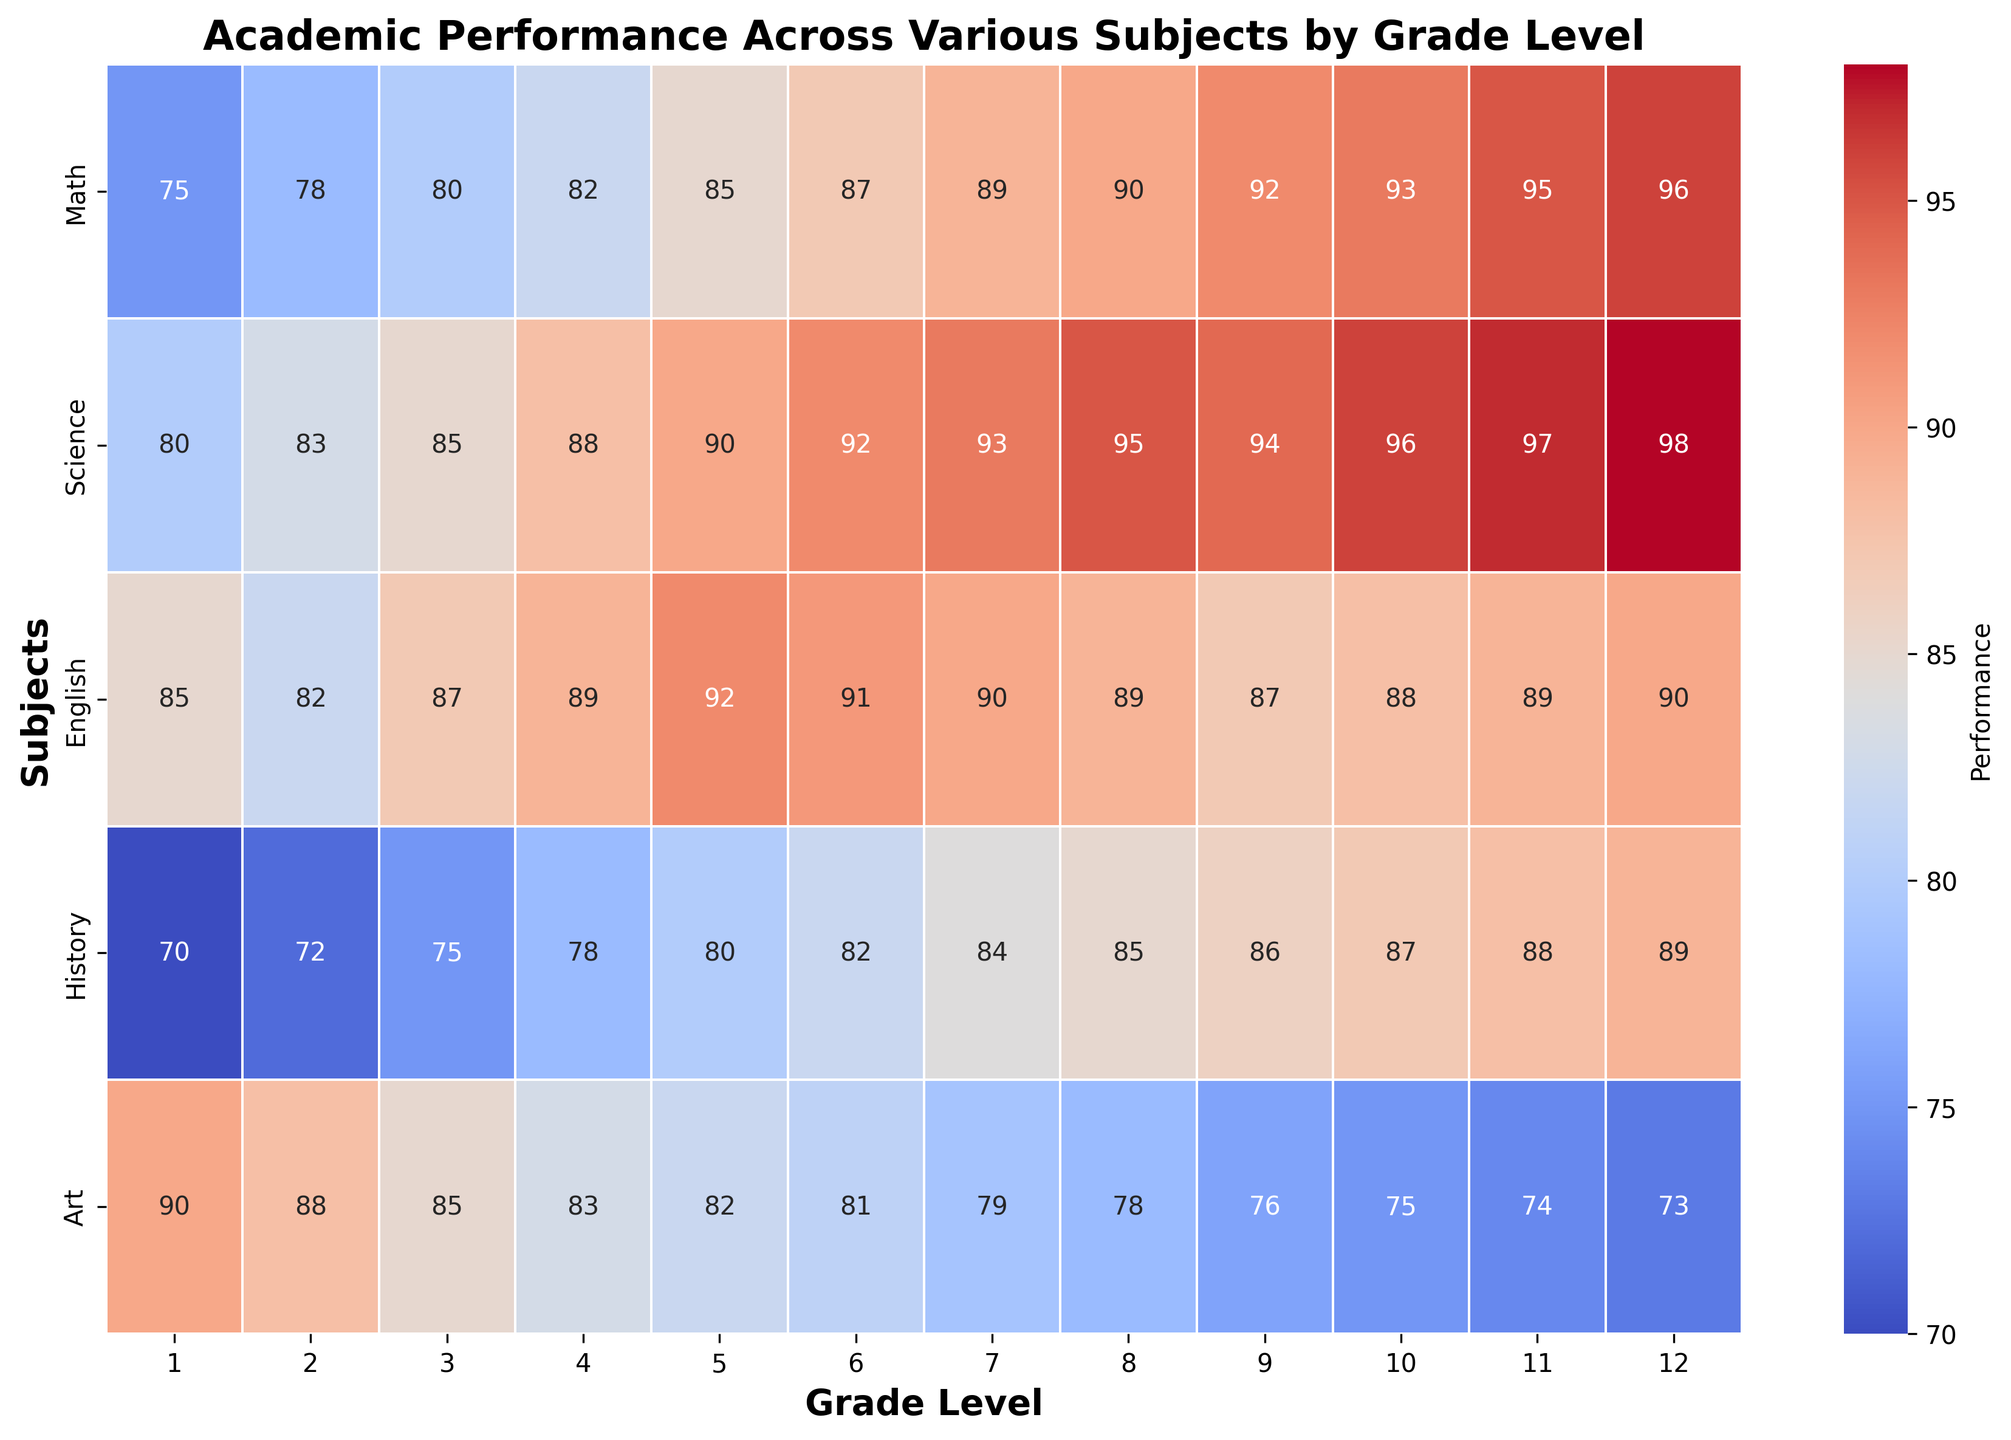What grade level has the highest average performance across all subjects? To find the grade level with the highest average performance, we need to calculate the average score for each grade level across all subjects. Grade 12 has the highest average of (96 + 98 + 90 + 89 + 73)/5 = 89.2.
Answer: Grade 12 Which subject shows the most significant improvement from Grade 1 to Grade 12? By comparing the scores from Grade 1 to Grade 12, Math goes from 75 to 96 (an increase of 21), Science goes from 80 to 98 (an increase of 18), English goes from 85 to 90 (an increase of 5), History goes from 70 to 89 (an increase of 19), and Art goes from 90 to 73 (a decrease). Math has the largest improvement with an increase of 21.
Answer: Math Are there any subjects where performance declines as grade level increases? Checking the scores from Grade 1 to Grade 12, we see that Art scores decline from 90 to 73 as the grade level increases.
Answer: Art What are the average scores for Science and History in Grade 8? The Science score for Grade 8 is 95 and the History score is 85. The average is (95 + 85) / 2 = 90.
Answer: 90 Is the performance in English higher in Grade 7 or Grade 11? In Grade 7, the English score is 90, while in Grade 11, it is 89. Therefore, the performance in English is higher in Grade 7.
Answer: Grade 7 Which grade level has the highest performance in Science and does it differ from the grade with the highest performance in English? The grade level with the highest performance in Science is Grade 12 with a score of 98. For English, the highest performance is also observed in Grade 5 with a score of 92.
Answer: No How does the Math score in Grade 6 compare to the History score in Grade 10? The Math score in Grade 6 is 87 and the History score in Grade 10 is 87. Therefore, both have the same score of 87.
Answer: Equal Between Grades 5 and 6, which grade shows better overall performance across all subjects? To determine this, find the average scores for both grades: Grade 5 - (85+90+92+80+82)/5 = 85.8 and Grade 6 - (87+92+91+82+81)/5 = 86.6. Therefore, Grade 6 shows better overall performance.
Answer: Grade 6 Which subject has the most consistent performance across all grade levels? Consistency can be measured by the variation in scores. English scores range from 82 (Grade 2) to 92 (Grade 5), showing minimal variation compared to other subjects.
Answer: English What is the trend in Art scores from Grades 1 to 12? Art scores show a decreasing trend from 90 in Grade 1 to 73 in Grade 12.
Answer: Decreasing 